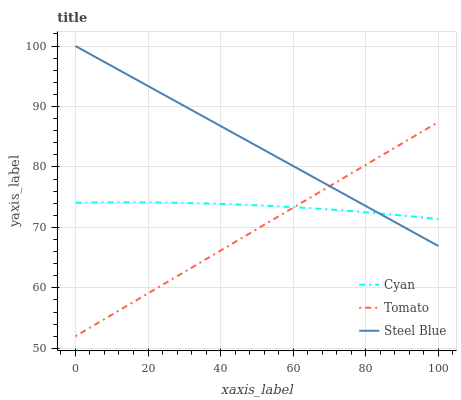Does Tomato have the minimum area under the curve?
Answer yes or no. Yes. Does Steel Blue have the maximum area under the curve?
Answer yes or no. Yes. Does Cyan have the minimum area under the curve?
Answer yes or no. No. Does Cyan have the maximum area under the curve?
Answer yes or no. No. Is Tomato the smoothest?
Answer yes or no. Yes. Is Cyan the roughest?
Answer yes or no. Yes. Is Steel Blue the smoothest?
Answer yes or no. No. Is Steel Blue the roughest?
Answer yes or no. No. Does Tomato have the lowest value?
Answer yes or no. Yes. Does Steel Blue have the lowest value?
Answer yes or no. No. Does Steel Blue have the highest value?
Answer yes or no. Yes. Does Cyan have the highest value?
Answer yes or no. No. Does Tomato intersect Steel Blue?
Answer yes or no. Yes. Is Tomato less than Steel Blue?
Answer yes or no. No. Is Tomato greater than Steel Blue?
Answer yes or no. No. 